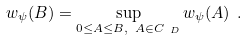Convert formula to latex. <formula><loc_0><loc_0><loc_500><loc_500>w _ { \psi } ( B ) = \sup _ { 0 \leq A \leq B , \ A \in C _ { \ D } } w _ { \psi } ( A ) \ .</formula> 